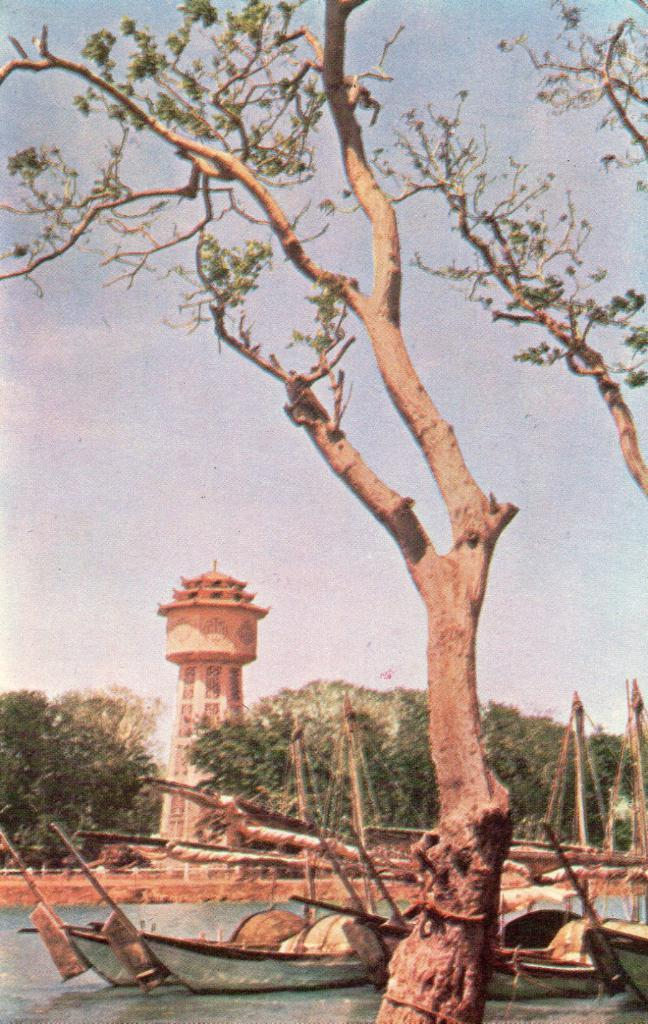What type of vehicles are in the water in the image? There are boats in the water in the image. What type of natural vegetation can be seen in the image? There are trees in the image. What architectural feature is present in the image? There appears to be a pillar in the image. What is visible at the top of the image? The sky is visible at the top of the image. Can you tell me how many umbrellas are open in the image? There are no umbrellas present in the image. What type of light source is illuminating the scene in the image? There is no specific light source mentioned or visible in the image. 